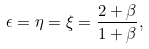Convert formula to latex. <formula><loc_0><loc_0><loc_500><loc_500>\epsilon = \eta = \xi = \frac { 2 + \beta } { 1 + \beta } ,</formula> 